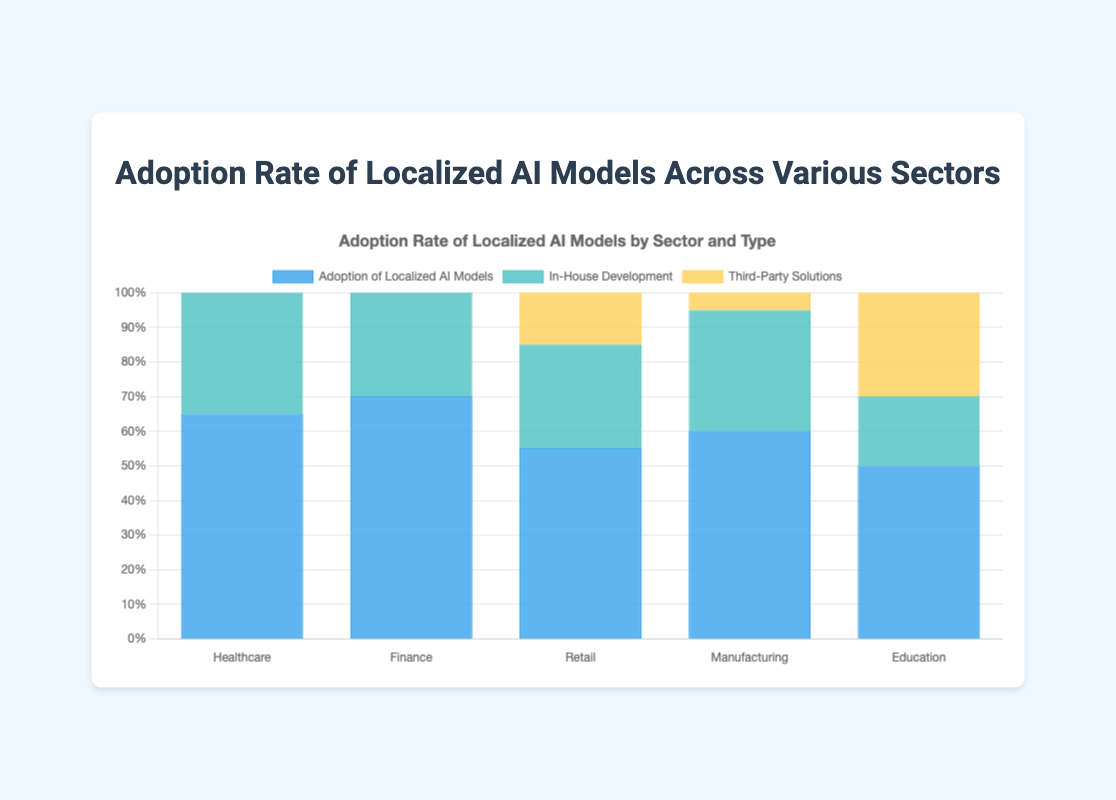Which sector has the highest adoption rate of localized AI models? The figure shows the adoption rates of localized AI models for various sectors with their percentage values. The sector with the highest bar for "Adoption of Localized AI Models" is Finance at 70%.
Answer: Finance What is the difference between the adoption rates of localized AI models in Healthcare and Education? We need to find the adoption rates for Healthcare and Education by looking at the heights of their bars for "Adoption of Localized AI Models": Healthcare is at 65% and Education is at 50%. The difference is 65% - 50% = 15%.
Answer: 15% In which sector is the proportion of in-house development higher than third-party solutions? By comparing the heights of the bars for "In-House Development" and "Third-Party Solutions" across all sectors, we can see that in Healthcare, Finance, Retail, and Manufacturing, the "In-House Development" bar is higher than the "Third-Party Solutions" bar. Education does not meet this criterion.
Answer: Healthcare, Finance, Retail, Manufacturing What is the combined percentage of in-house development and third-party solutions in Finance? In Finance, the "In-House Development" percentage is 45% and "Third-Party Solutions" is 25%. Therefore, the combined percentage is 45% + 25% = 70%.
Answer: 70% How many sectors have a higher adoption rate of localized AI models than Retail? Retail has an adoption rate of 55%. We need to count the sectors with a rate higher than 55%. Healthcare (65%), Finance (70%), and Manufacturing (60%) all have higher rates. Therefore, there are 3 sectors.
Answer: 3 What is the average adoption rate of localized AI models across all sectors? The adoption rates for all sectors are: Healthcare (65%), Finance (70%), Retail (55%), Manufacturing (60%), and Education (50%). The sum is 65 + 70 + 55 + 60 + 50 = 300, and there are 5 sectors. The average is 300 / 5 = 60%.
Answer: 60% Which sector has the smallest difference in percentage between in-house development and third-party solutions? We need to find the difference between "In-House Development" and "Third-Party Solutions" for each sector: Healthcare (40% - 25% = 15%), Finance (45% - 25% = 20%), Retail (30% - 25% = 5%), Manufacturing (35% - 25% = 10%), Education (20% - 30% = -10%). The smallest absolute difference is in Education with 10%.
Answer: Education In terms of the highest total percentage of all three categories (adoption of localized AI models, in-house development, and third-party solutions combined), which sector leads? We need to sum up the percentages for the three categories in each sector. By observation, Finance: 70% + 45% + 25% = 140%. The other sectors have lower combined percentages. Thus, Finance leads.
Answer: Finance 